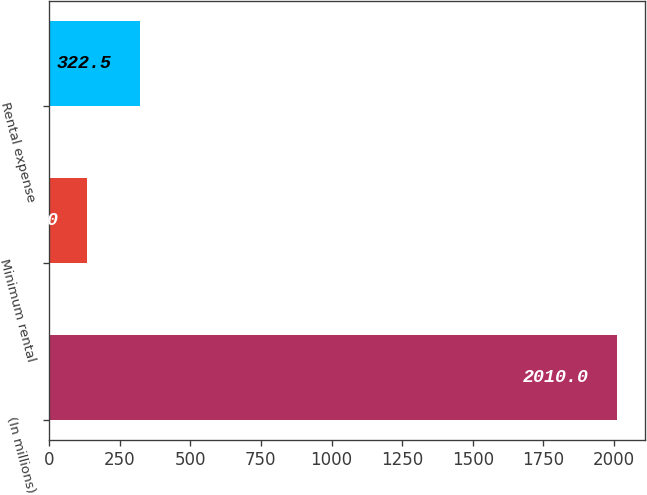Convert chart to OTSL. <chart><loc_0><loc_0><loc_500><loc_500><bar_chart><fcel>(In millions)<fcel>Minimum rental<fcel>Rental expense<nl><fcel>2010<fcel>135<fcel>322.5<nl></chart> 